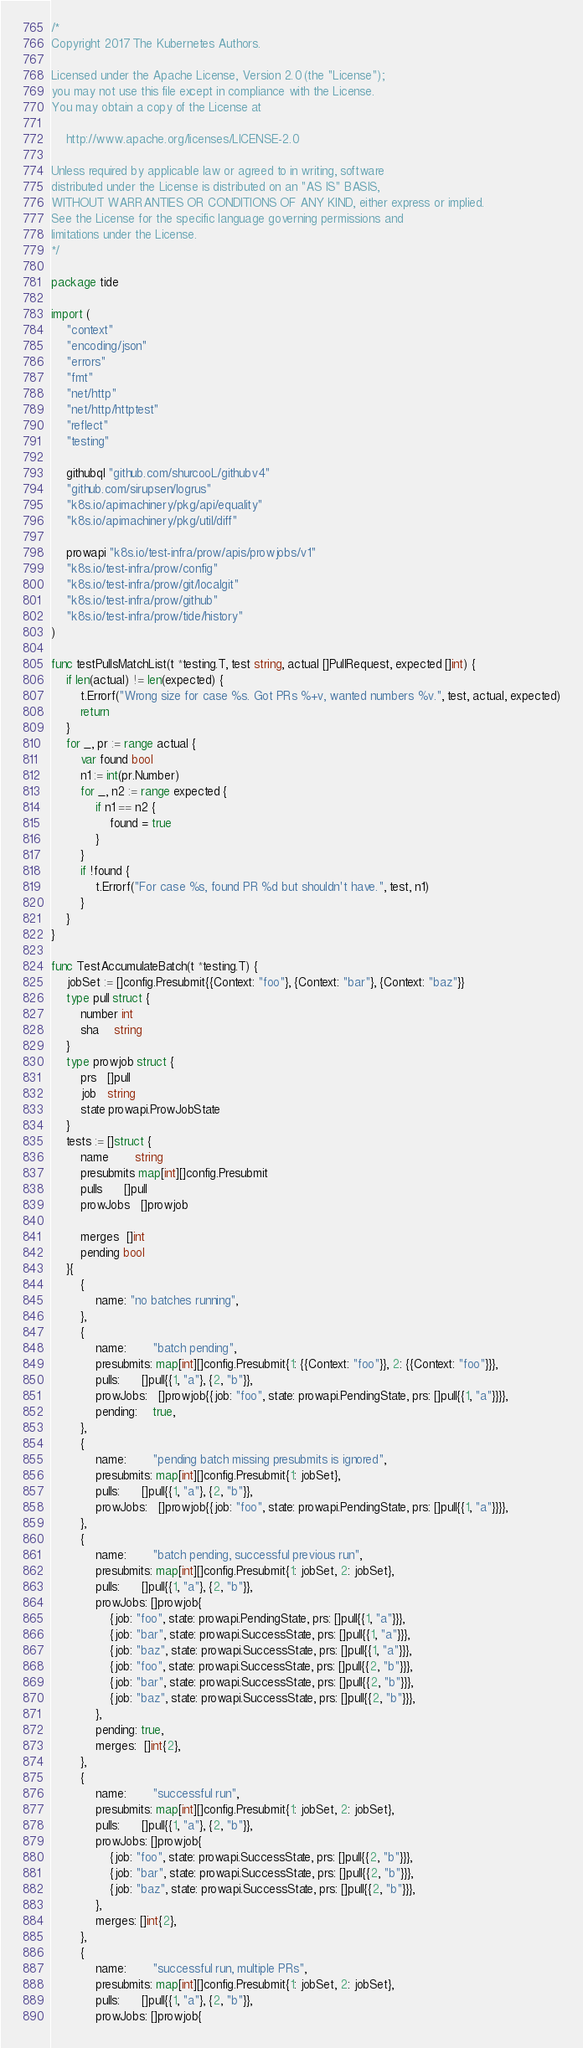<code> <loc_0><loc_0><loc_500><loc_500><_Go_>/*
Copyright 2017 The Kubernetes Authors.

Licensed under the Apache License, Version 2.0 (the "License");
you may not use this file except in compliance with the License.
You may obtain a copy of the License at

    http://www.apache.org/licenses/LICENSE-2.0

Unless required by applicable law or agreed to in writing, software
distributed under the License is distributed on an "AS IS" BASIS,
WITHOUT WARRANTIES OR CONDITIONS OF ANY KIND, either express or implied.
See the License for the specific language governing permissions and
limitations under the License.
*/

package tide

import (
	"context"
	"encoding/json"
	"errors"
	"fmt"
	"net/http"
	"net/http/httptest"
	"reflect"
	"testing"

	githubql "github.com/shurcooL/githubv4"
	"github.com/sirupsen/logrus"
	"k8s.io/apimachinery/pkg/api/equality"
	"k8s.io/apimachinery/pkg/util/diff"

	prowapi "k8s.io/test-infra/prow/apis/prowjobs/v1"
	"k8s.io/test-infra/prow/config"
	"k8s.io/test-infra/prow/git/localgit"
	"k8s.io/test-infra/prow/github"
	"k8s.io/test-infra/prow/tide/history"
)

func testPullsMatchList(t *testing.T, test string, actual []PullRequest, expected []int) {
	if len(actual) != len(expected) {
		t.Errorf("Wrong size for case %s. Got PRs %+v, wanted numbers %v.", test, actual, expected)
		return
	}
	for _, pr := range actual {
		var found bool
		n1 := int(pr.Number)
		for _, n2 := range expected {
			if n1 == n2 {
				found = true
			}
		}
		if !found {
			t.Errorf("For case %s, found PR %d but shouldn't have.", test, n1)
		}
	}
}

func TestAccumulateBatch(t *testing.T) {
	jobSet := []config.Presubmit{{Context: "foo"}, {Context: "bar"}, {Context: "baz"}}
	type pull struct {
		number int
		sha    string
	}
	type prowjob struct {
		prs   []pull
		job   string
		state prowapi.ProwJobState
	}
	tests := []struct {
		name       string
		presubmits map[int][]config.Presubmit
		pulls      []pull
		prowJobs   []prowjob

		merges  []int
		pending bool
	}{
		{
			name: "no batches running",
		},
		{
			name:       "batch pending",
			presubmits: map[int][]config.Presubmit{1: {{Context: "foo"}}, 2: {{Context: "foo"}}},
			pulls:      []pull{{1, "a"}, {2, "b"}},
			prowJobs:   []prowjob{{job: "foo", state: prowapi.PendingState, prs: []pull{{1, "a"}}}},
			pending:    true,
		},
		{
			name:       "pending batch missing presubmits is ignored",
			presubmits: map[int][]config.Presubmit{1: jobSet},
			pulls:      []pull{{1, "a"}, {2, "b"}},
			prowJobs:   []prowjob{{job: "foo", state: prowapi.PendingState, prs: []pull{{1, "a"}}}},
		},
		{
			name:       "batch pending, successful previous run",
			presubmits: map[int][]config.Presubmit{1: jobSet, 2: jobSet},
			pulls:      []pull{{1, "a"}, {2, "b"}},
			prowJobs: []prowjob{
				{job: "foo", state: prowapi.PendingState, prs: []pull{{1, "a"}}},
				{job: "bar", state: prowapi.SuccessState, prs: []pull{{1, "a"}}},
				{job: "baz", state: prowapi.SuccessState, prs: []pull{{1, "a"}}},
				{job: "foo", state: prowapi.SuccessState, prs: []pull{{2, "b"}}},
				{job: "bar", state: prowapi.SuccessState, prs: []pull{{2, "b"}}},
				{job: "baz", state: prowapi.SuccessState, prs: []pull{{2, "b"}}},
			},
			pending: true,
			merges:  []int{2},
		},
		{
			name:       "successful run",
			presubmits: map[int][]config.Presubmit{1: jobSet, 2: jobSet},
			pulls:      []pull{{1, "a"}, {2, "b"}},
			prowJobs: []prowjob{
				{job: "foo", state: prowapi.SuccessState, prs: []pull{{2, "b"}}},
				{job: "bar", state: prowapi.SuccessState, prs: []pull{{2, "b"}}},
				{job: "baz", state: prowapi.SuccessState, prs: []pull{{2, "b"}}},
			},
			merges: []int{2},
		},
		{
			name:       "successful run, multiple PRs",
			presubmits: map[int][]config.Presubmit{1: jobSet, 2: jobSet},
			pulls:      []pull{{1, "a"}, {2, "b"}},
			prowJobs: []prowjob{</code> 